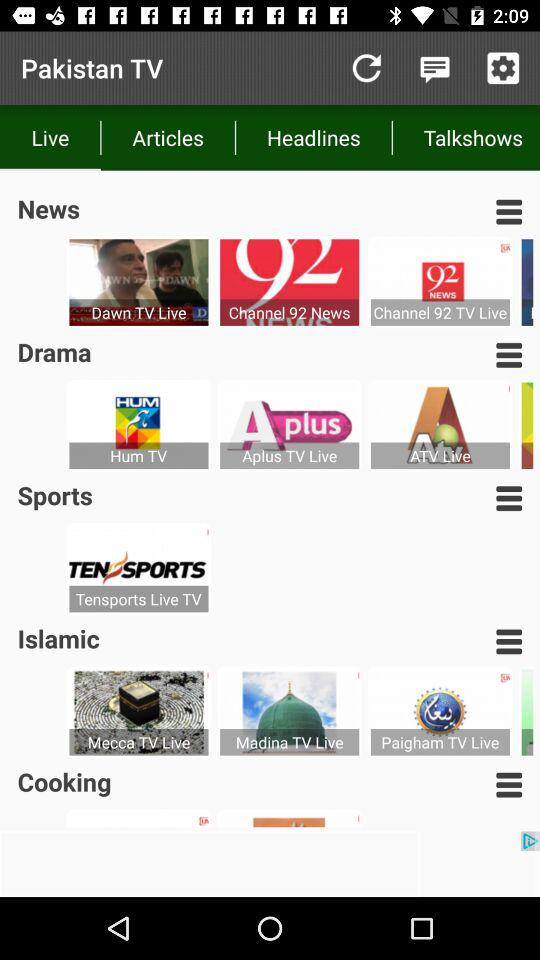What is the name of the application? The name of the application is "Pakistan TV". 